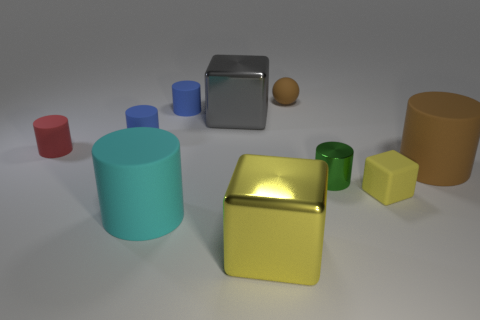Is there anything else that has the same shape as the tiny brown rubber thing? If you are referring to the small spherical object, the similarly shaped item in this image would be the larger orange sphere. Both share a round shape, though their sizes differ. 